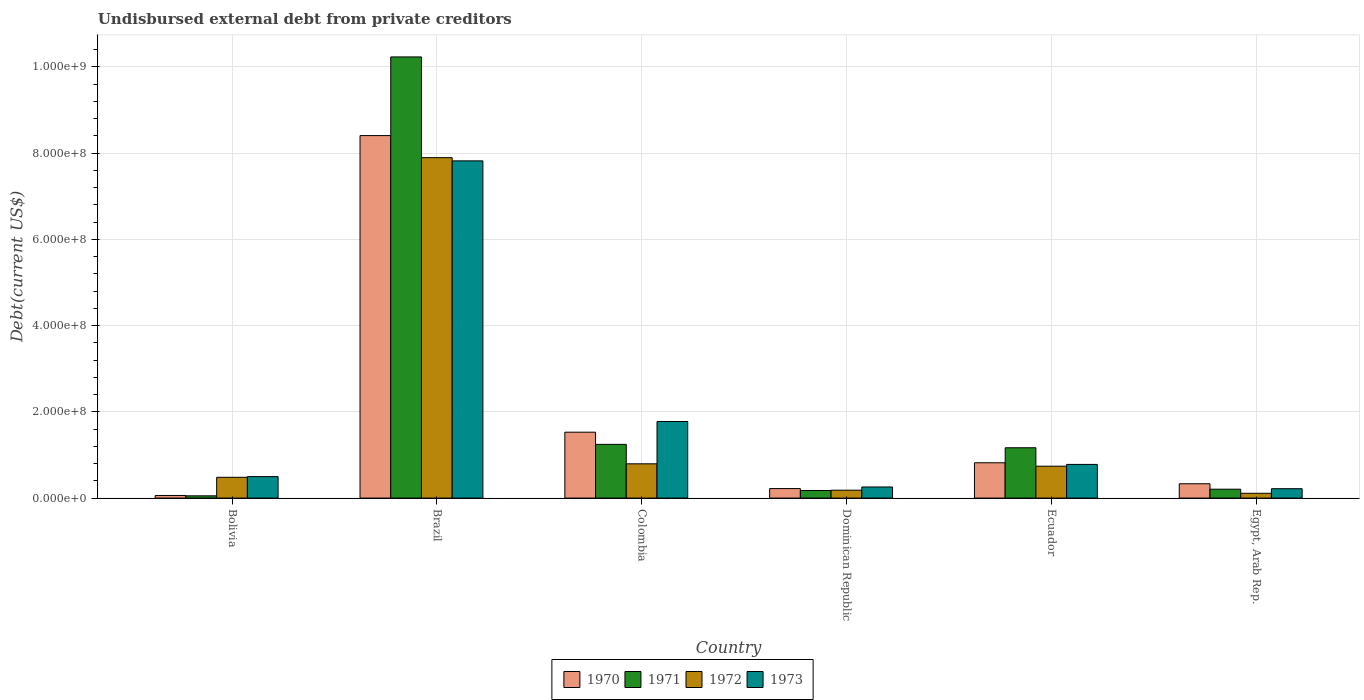Are the number of bars per tick equal to the number of legend labels?
Your answer should be very brief. Yes. How many bars are there on the 4th tick from the right?
Your answer should be very brief. 4. What is the label of the 2nd group of bars from the left?
Ensure brevity in your answer.  Brazil. What is the total debt in 1971 in Bolivia?
Your response must be concise. 5.25e+06. Across all countries, what is the maximum total debt in 1970?
Provide a short and direct response. 8.41e+08. Across all countries, what is the minimum total debt in 1973?
Offer a very short reply. 2.18e+07. In which country was the total debt in 1970 maximum?
Provide a succinct answer. Brazil. In which country was the total debt in 1973 minimum?
Your answer should be very brief. Egypt, Arab Rep. What is the total total debt in 1972 in the graph?
Offer a terse response. 1.02e+09. What is the difference between the total debt in 1971 in Bolivia and that in Brazil?
Ensure brevity in your answer.  -1.02e+09. What is the difference between the total debt in 1970 in Ecuador and the total debt in 1973 in Dominican Republic?
Ensure brevity in your answer.  5.61e+07. What is the average total debt in 1971 per country?
Make the answer very short. 2.18e+08. What is the difference between the total debt of/in 1973 and total debt of/in 1970 in Ecuador?
Your answer should be compact. -3.78e+06. What is the ratio of the total debt in 1972 in Bolivia to that in Ecuador?
Ensure brevity in your answer.  0.65. Is the total debt in 1971 in Bolivia less than that in Dominican Republic?
Give a very brief answer. Yes. Is the difference between the total debt in 1973 in Brazil and Egypt, Arab Rep. greater than the difference between the total debt in 1970 in Brazil and Egypt, Arab Rep.?
Offer a very short reply. No. What is the difference between the highest and the second highest total debt in 1970?
Provide a succinct answer. 7.59e+08. What is the difference between the highest and the lowest total debt in 1972?
Offer a terse response. 7.78e+08. In how many countries, is the total debt in 1971 greater than the average total debt in 1971 taken over all countries?
Offer a very short reply. 1. Is the sum of the total debt in 1972 in Ecuador and Egypt, Arab Rep. greater than the maximum total debt in 1971 across all countries?
Your answer should be compact. No. Is it the case that in every country, the sum of the total debt in 1971 and total debt in 1970 is greater than the sum of total debt in 1973 and total debt in 1972?
Provide a succinct answer. No. Is it the case that in every country, the sum of the total debt in 1973 and total debt in 1972 is greater than the total debt in 1970?
Your answer should be very brief. No. Are all the bars in the graph horizontal?
Offer a terse response. No. How many countries are there in the graph?
Your response must be concise. 6. What is the difference between two consecutive major ticks on the Y-axis?
Give a very brief answer. 2.00e+08. Are the values on the major ticks of Y-axis written in scientific E-notation?
Offer a terse response. Yes. Does the graph contain grids?
Ensure brevity in your answer.  Yes. What is the title of the graph?
Your answer should be very brief. Undisbursed external debt from private creditors. What is the label or title of the X-axis?
Give a very brief answer. Country. What is the label or title of the Y-axis?
Offer a very short reply. Debt(current US$). What is the Debt(current US$) in 1970 in Bolivia?
Your answer should be compact. 6.05e+06. What is the Debt(current US$) in 1971 in Bolivia?
Keep it short and to the point. 5.25e+06. What is the Debt(current US$) in 1972 in Bolivia?
Give a very brief answer. 4.82e+07. What is the Debt(current US$) of 1973 in Bolivia?
Your answer should be compact. 4.98e+07. What is the Debt(current US$) in 1970 in Brazil?
Provide a short and direct response. 8.41e+08. What is the Debt(current US$) in 1971 in Brazil?
Offer a terse response. 1.02e+09. What is the Debt(current US$) in 1972 in Brazil?
Your response must be concise. 7.89e+08. What is the Debt(current US$) of 1973 in Brazil?
Offer a very short reply. 7.82e+08. What is the Debt(current US$) of 1970 in Colombia?
Make the answer very short. 1.53e+08. What is the Debt(current US$) of 1971 in Colombia?
Make the answer very short. 1.25e+08. What is the Debt(current US$) of 1972 in Colombia?
Your answer should be very brief. 7.95e+07. What is the Debt(current US$) in 1973 in Colombia?
Keep it short and to the point. 1.78e+08. What is the Debt(current US$) in 1970 in Dominican Republic?
Provide a succinct answer. 2.21e+07. What is the Debt(current US$) in 1971 in Dominican Republic?
Make the answer very short. 1.76e+07. What is the Debt(current US$) of 1972 in Dominican Republic?
Your answer should be very brief. 1.83e+07. What is the Debt(current US$) in 1973 in Dominican Republic?
Provide a short and direct response. 2.58e+07. What is the Debt(current US$) in 1970 in Ecuador?
Provide a succinct answer. 8.19e+07. What is the Debt(current US$) in 1971 in Ecuador?
Give a very brief answer. 1.17e+08. What is the Debt(current US$) in 1972 in Ecuador?
Your answer should be compact. 7.40e+07. What is the Debt(current US$) of 1973 in Ecuador?
Provide a succinct answer. 7.81e+07. What is the Debt(current US$) of 1970 in Egypt, Arab Rep.?
Offer a very short reply. 3.32e+07. What is the Debt(current US$) in 1971 in Egypt, Arab Rep.?
Ensure brevity in your answer.  2.06e+07. What is the Debt(current US$) in 1972 in Egypt, Arab Rep.?
Provide a succinct answer. 1.11e+07. What is the Debt(current US$) of 1973 in Egypt, Arab Rep.?
Give a very brief answer. 2.18e+07. Across all countries, what is the maximum Debt(current US$) in 1970?
Ensure brevity in your answer.  8.41e+08. Across all countries, what is the maximum Debt(current US$) of 1971?
Your answer should be compact. 1.02e+09. Across all countries, what is the maximum Debt(current US$) of 1972?
Provide a short and direct response. 7.89e+08. Across all countries, what is the maximum Debt(current US$) of 1973?
Offer a very short reply. 7.82e+08. Across all countries, what is the minimum Debt(current US$) of 1970?
Give a very brief answer. 6.05e+06. Across all countries, what is the minimum Debt(current US$) in 1971?
Your answer should be very brief. 5.25e+06. Across all countries, what is the minimum Debt(current US$) of 1972?
Your response must be concise. 1.11e+07. Across all countries, what is the minimum Debt(current US$) in 1973?
Provide a short and direct response. 2.18e+07. What is the total Debt(current US$) in 1970 in the graph?
Keep it short and to the point. 1.14e+09. What is the total Debt(current US$) in 1971 in the graph?
Ensure brevity in your answer.  1.31e+09. What is the total Debt(current US$) in 1972 in the graph?
Keep it short and to the point. 1.02e+09. What is the total Debt(current US$) of 1973 in the graph?
Your answer should be compact. 1.14e+09. What is the difference between the Debt(current US$) of 1970 in Bolivia and that in Brazil?
Your response must be concise. -8.35e+08. What is the difference between the Debt(current US$) in 1971 in Bolivia and that in Brazil?
Provide a short and direct response. -1.02e+09. What is the difference between the Debt(current US$) of 1972 in Bolivia and that in Brazil?
Your response must be concise. -7.41e+08. What is the difference between the Debt(current US$) in 1973 in Bolivia and that in Brazil?
Offer a terse response. -7.32e+08. What is the difference between the Debt(current US$) in 1970 in Bolivia and that in Colombia?
Your answer should be compact. -1.47e+08. What is the difference between the Debt(current US$) of 1971 in Bolivia and that in Colombia?
Keep it short and to the point. -1.19e+08. What is the difference between the Debt(current US$) in 1972 in Bolivia and that in Colombia?
Give a very brief answer. -3.13e+07. What is the difference between the Debt(current US$) in 1973 in Bolivia and that in Colombia?
Offer a terse response. -1.28e+08. What is the difference between the Debt(current US$) of 1970 in Bolivia and that in Dominican Republic?
Ensure brevity in your answer.  -1.60e+07. What is the difference between the Debt(current US$) of 1971 in Bolivia and that in Dominican Republic?
Offer a terse response. -1.24e+07. What is the difference between the Debt(current US$) of 1972 in Bolivia and that in Dominican Republic?
Your answer should be very brief. 2.99e+07. What is the difference between the Debt(current US$) of 1973 in Bolivia and that in Dominican Republic?
Offer a terse response. 2.40e+07. What is the difference between the Debt(current US$) in 1970 in Bolivia and that in Ecuador?
Provide a succinct answer. -7.58e+07. What is the difference between the Debt(current US$) of 1971 in Bolivia and that in Ecuador?
Offer a terse response. -1.11e+08. What is the difference between the Debt(current US$) of 1972 in Bolivia and that in Ecuador?
Your response must be concise. -2.58e+07. What is the difference between the Debt(current US$) of 1973 in Bolivia and that in Ecuador?
Give a very brief answer. -2.83e+07. What is the difference between the Debt(current US$) of 1970 in Bolivia and that in Egypt, Arab Rep.?
Make the answer very short. -2.72e+07. What is the difference between the Debt(current US$) of 1971 in Bolivia and that in Egypt, Arab Rep.?
Your response must be concise. -1.54e+07. What is the difference between the Debt(current US$) of 1972 in Bolivia and that in Egypt, Arab Rep.?
Make the answer very short. 3.71e+07. What is the difference between the Debt(current US$) of 1973 in Bolivia and that in Egypt, Arab Rep.?
Ensure brevity in your answer.  2.80e+07. What is the difference between the Debt(current US$) of 1970 in Brazil and that in Colombia?
Ensure brevity in your answer.  6.88e+08. What is the difference between the Debt(current US$) in 1971 in Brazil and that in Colombia?
Your response must be concise. 8.98e+08. What is the difference between the Debt(current US$) of 1972 in Brazil and that in Colombia?
Provide a short and direct response. 7.10e+08. What is the difference between the Debt(current US$) in 1973 in Brazil and that in Colombia?
Your answer should be compact. 6.04e+08. What is the difference between the Debt(current US$) of 1970 in Brazil and that in Dominican Republic?
Offer a terse response. 8.19e+08. What is the difference between the Debt(current US$) of 1971 in Brazil and that in Dominican Republic?
Offer a very short reply. 1.01e+09. What is the difference between the Debt(current US$) of 1972 in Brazil and that in Dominican Republic?
Give a very brief answer. 7.71e+08. What is the difference between the Debt(current US$) in 1973 in Brazil and that in Dominican Republic?
Provide a short and direct response. 7.56e+08. What is the difference between the Debt(current US$) in 1970 in Brazil and that in Ecuador?
Give a very brief answer. 7.59e+08. What is the difference between the Debt(current US$) of 1971 in Brazil and that in Ecuador?
Ensure brevity in your answer.  9.06e+08. What is the difference between the Debt(current US$) in 1972 in Brazil and that in Ecuador?
Your response must be concise. 7.15e+08. What is the difference between the Debt(current US$) of 1973 in Brazil and that in Ecuador?
Provide a short and direct response. 7.04e+08. What is the difference between the Debt(current US$) of 1970 in Brazil and that in Egypt, Arab Rep.?
Your answer should be compact. 8.07e+08. What is the difference between the Debt(current US$) of 1971 in Brazil and that in Egypt, Arab Rep.?
Provide a succinct answer. 1.00e+09. What is the difference between the Debt(current US$) in 1972 in Brazil and that in Egypt, Arab Rep.?
Your answer should be compact. 7.78e+08. What is the difference between the Debt(current US$) in 1973 in Brazil and that in Egypt, Arab Rep.?
Offer a very short reply. 7.60e+08. What is the difference between the Debt(current US$) in 1970 in Colombia and that in Dominican Republic?
Your answer should be very brief. 1.31e+08. What is the difference between the Debt(current US$) of 1971 in Colombia and that in Dominican Republic?
Your answer should be compact. 1.07e+08. What is the difference between the Debt(current US$) of 1972 in Colombia and that in Dominican Republic?
Your answer should be very brief. 6.12e+07. What is the difference between the Debt(current US$) of 1973 in Colombia and that in Dominican Republic?
Keep it short and to the point. 1.52e+08. What is the difference between the Debt(current US$) of 1970 in Colombia and that in Ecuador?
Offer a terse response. 7.09e+07. What is the difference between the Debt(current US$) in 1971 in Colombia and that in Ecuador?
Offer a terse response. 7.88e+06. What is the difference between the Debt(current US$) in 1972 in Colombia and that in Ecuador?
Make the answer very short. 5.49e+06. What is the difference between the Debt(current US$) of 1973 in Colombia and that in Ecuador?
Ensure brevity in your answer.  9.95e+07. What is the difference between the Debt(current US$) in 1970 in Colombia and that in Egypt, Arab Rep.?
Ensure brevity in your answer.  1.20e+08. What is the difference between the Debt(current US$) of 1971 in Colombia and that in Egypt, Arab Rep.?
Offer a terse response. 1.04e+08. What is the difference between the Debt(current US$) in 1972 in Colombia and that in Egypt, Arab Rep.?
Your answer should be very brief. 6.83e+07. What is the difference between the Debt(current US$) in 1973 in Colombia and that in Egypt, Arab Rep.?
Offer a terse response. 1.56e+08. What is the difference between the Debt(current US$) in 1970 in Dominican Republic and that in Ecuador?
Your answer should be compact. -5.98e+07. What is the difference between the Debt(current US$) in 1971 in Dominican Republic and that in Ecuador?
Make the answer very short. -9.91e+07. What is the difference between the Debt(current US$) in 1972 in Dominican Republic and that in Ecuador?
Your response must be concise. -5.57e+07. What is the difference between the Debt(current US$) in 1973 in Dominican Republic and that in Ecuador?
Give a very brief answer. -5.23e+07. What is the difference between the Debt(current US$) of 1970 in Dominican Republic and that in Egypt, Arab Rep.?
Give a very brief answer. -1.11e+07. What is the difference between the Debt(current US$) in 1971 in Dominican Republic and that in Egypt, Arab Rep.?
Your answer should be compact. -3.00e+06. What is the difference between the Debt(current US$) of 1972 in Dominican Republic and that in Egypt, Arab Rep.?
Your response must be concise. 7.19e+06. What is the difference between the Debt(current US$) of 1973 in Dominican Republic and that in Egypt, Arab Rep.?
Give a very brief answer. 3.97e+06. What is the difference between the Debt(current US$) in 1970 in Ecuador and that in Egypt, Arab Rep.?
Ensure brevity in your answer.  4.87e+07. What is the difference between the Debt(current US$) in 1971 in Ecuador and that in Egypt, Arab Rep.?
Ensure brevity in your answer.  9.61e+07. What is the difference between the Debt(current US$) of 1972 in Ecuador and that in Egypt, Arab Rep.?
Provide a short and direct response. 6.28e+07. What is the difference between the Debt(current US$) of 1973 in Ecuador and that in Egypt, Arab Rep.?
Your answer should be compact. 5.63e+07. What is the difference between the Debt(current US$) of 1970 in Bolivia and the Debt(current US$) of 1971 in Brazil?
Keep it short and to the point. -1.02e+09. What is the difference between the Debt(current US$) of 1970 in Bolivia and the Debt(current US$) of 1972 in Brazil?
Ensure brevity in your answer.  -7.83e+08. What is the difference between the Debt(current US$) of 1970 in Bolivia and the Debt(current US$) of 1973 in Brazil?
Your answer should be compact. -7.76e+08. What is the difference between the Debt(current US$) of 1971 in Bolivia and the Debt(current US$) of 1972 in Brazil?
Provide a short and direct response. -7.84e+08. What is the difference between the Debt(current US$) of 1971 in Bolivia and the Debt(current US$) of 1973 in Brazil?
Your answer should be very brief. -7.77e+08. What is the difference between the Debt(current US$) of 1972 in Bolivia and the Debt(current US$) of 1973 in Brazil?
Your answer should be very brief. -7.34e+08. What is the difference between the Debt(current US$) in 1970 in Bolivia and the Debt(current US$) in 1971 in Colombia?
Offer a terse response. -1.19e+08. What is the difference between the Debt(current US$) in 1970 in Bolivia and the Debt(current US$) in 1972 in Colombia?
Provide a succinct answer. -7.34e+07. What is the difference between the Debt(current US$) in 1970 in Bolivia and the Debt(current US$) in 1973 in Colombia?
Offer a very short reply. -1.72e+08. What is the difference between the Debt(current US$) of 1971 in Bolivia and the Debt(current US$) of 1972 in Colombia?
Provide a succinct answer. -7.42e+07. What is the difference between the Debt(current US$) in 1971 in Bolivia and the Debt(current US$) in 1973 in Colombia?
Provide a short and direct response. -1.72e+08. What is the difference between the Debt(current US$) of 1972 in Bolivia and the Debt(current US$) of 1973 in Colombia?
Give a very brief answer. -1.29e+08. What is the difference between the Debt(current US$) in 1970 in Bolivia and the Debt(current US$) in 1971 in Dominican Republic?
Make the answer very short. -1.16e+07. What is the difference between the Debt(current US$) in 1970 in Bolivia and the Debt(current US$) in 1972 in Dominican Republic?
Offer a very short reply. -1.23e+07. What is the difference between the Debt(current US$) in 1970 in Bolivia and the Debt(current US$) in 1973 in Dominican Republic?
Ensure brevity in your answer.  -1.97e+07. What is the difference between the Debt(current US$) of 1971 in Bolivia and the Debt(current US$) of 1972 in Dominican Republic?
Make the answer very short. -1.31e+07. What is the difference between the Debt(current US$) in 1971 in Bolivia and the Debt(current US$) in 1973 in Dominican Republic?
Your answer should be compact. -2.05e+07. What is the difference between the Debt(current US$) of 1972 in Bolivia and the Debt(current US$) of 1973 in Dominican Republic?
Offer a very short reply. 2.24e+07. What is the difference between the Debt(current US$) of 1970 in Bolivia and the Debt(current US$) of 1971 in Ecuador?
Give a very brief answer. -1.11e+08. What is the difference between the Debt(current US$) of 1970 in Bolivia and the Debt(current US$) of 1972 in Ecuador?
Provide a succinct answer. -6.79e+07. What is the difference between the Debt(current US$) in 1970 in Bolivia and the Debt(current US$) in 1973 in Ecuador?
Provide a short and direct response. -7.21e+07. What is the difference between the Debt(current US$) in 1971 in Bolivia and the Debt(current US$) in 1972 in Ecuador?
Provide a short and direct response. -6.87e+07. What is the difference between the Debt(current US$) in 1971 in Bolivia and the Debt(current US$) in 1973 in Ecuador?
Offer a very short reply. -7.29e+07. What is the difference between the Debt(current US$) of 1972 in Bolivia and the Debt(current US$) of 1973 in Ecuador?
Give a very brief answer. -2.99e+07. What is the difference between the Debt(current US$) in 1970 in Bolivia and the Debt(current US$) in 1971 in Egypt, Arab Rep.?
Your answer should be compact. -1.46e+07. What is the difference between the Debt(current US$) of 1970 in Bolivia and the Debt(current US$) of 1972 in Egypt, Arab Rep.?
Offer a very short reply. -5.08e+06. What is the difference between the Debt(current US$) of 1970 in Bolivia and the Debt(current US$) of 1973 in Egypt, Arab Rep.?
Ensure brevity in your answer.  -1.58e+07. What is the difference between the Debt(current US$) of 1971 in Bolivia and the Debt(current US$) of 1972 in Egypt, Arab Rep.?
Provide a succinct answer. -5.88e+06. What is the difference between the Debt(current US$) in 1971 in Bolivia and the Debt(current US$) in 1973 in Egypt, Arab Rep.?
Make the answer very short. -1.66e+07. What is the difference between the Debt(current US$) in 1972 in Bolivia and the Debt(current US$) in 1973 in Egypt, Arab Rep.?
Make the answer very short. 2.64e+07. What is the difference between the Debt(current US$) of 1970 in Brazil and the Debt(current US$) of 1971 in Colombia?
Make the answer very short. 7.16e+08. What is the difference between the Debt(current US$) in 1970 in Brazil and the Debt(current US$) in 1972 in Colombia?
Make the answer very short. 7.61e+08. What is the difference between the Debt(current US$) of 1970 in Brazil and the Debt(current US$) of 1973 in Colombia?
Provide a succinct answer. 6.63e+08. What is the difference between the Debt(current US$) of 1971 in Brazil and the Debt(current US$) of 1972 in Colombia?
Your answer should be compact. 9.44e+08. What is the difference between the Debt(current US$) in 1971 in Brazil and the Debt(current US$) in 1973 in Colombia?
Offer a terse response. 8.45e+08. What is the difference between the Debt(current US$) of 1972 in Brazil and the Debt(current US$) of 1973 in Colombia?
Provide a succinct answer. 6.12e+08. What is the difference between the Debt(current US$) in 1970 in Brazil and the Debt(current US$) in 1971 in Dominican Republic?
Provide a short and direct response. 8.23e+08. What is the difference between the Debt(current US$) of 1970 in Brazil and the Debt(current US$) of 1972 in Dominican Republic?
Offer a very short reply. 8.22e+08. What is the difference between the Debt(current US$) of 1970 in Brazil and the Debt(current US$) of 1973 in Dominican Republic?
Ensure brevity in your answer.  8.15e+08. What is the difference between the Debt(current US$) of 1971 in Brazil and the Debt(current US$) of 1972 in Dominican Republic?
Your answer should be very brief. 1.00e+09. What is the difference between the Debt(current US$) of 1971 in Brazil and the Debt(current US$) of 1973 in Dominican Republic?
Provide a short and direct response. 9.97e+08. What is the difference between the Debt(current US$) of 1972 in Brazil and the Debt(current US$) of 1973 in Dominican Republic?
Offer a very short reply. 7.64e+08. What is the difference between the Debt(current US$) of 1970 in Brazil and the Debt(current US$) of 1971 in Ecuador?
Provide a short and direct response. 7.24e+08. What is the difference between the Debt(current US$) of 1970 in Brazil and the Debt(current US$) of 1972 in Ecuador?
Offer a terse response. 7.67e+08. What is the difference between the Debt(current US$) in 1970 in Brazil and the Debt(current US$) in 1973 in Ecuador?
Provide a short and direct response. 7.63e+08. What is the difference between the Debt(current US$) in 1971 in Brazil and the Debt(current US$) in 1972 in Ecuador?
Give a very brief answer. 9.49e+08. What is the difference between the Debt(current US$) in 1971 in Brazil and the Debt(current US$) in 1973 in Ecuador?
Offer a terse response. 9.45e+08. What is the difference between the Debt(current US$) in 1972 in Brazil and the Debt(current US$) in 1973 in Ecuador?
Offer a terse response. 7.11e+08. What is the difference between the Debt(current US$) in 1970 in Brazil and the Debt(current US$) in 1971 in Egypt, Arab Rep.?
Offer a terse response. 8.20e+08. What is the difference between the Debt(current US$) of 1970 in Brazil and the Debt(current US$) of 1972 in Egypt, Arab Rep.?
Offer a very short reply. 8.29e+08. What is the difference between the Debt(current US$) of 1970 in Brazil and the Debt(current US$) of 1973 in Egypt, Arab Rep.?
Offer a terse response. 8.19e+08. What is the difference between the Debt(current US$) of 1971 in Brazil and the Debt(current US$) of 1972 in Egypt, Arab Rep.?
Your answer should be very brief. 1.01e+09. What is the difference between the Debt(current US$) of 1971 in Brazil and the Debt(current US$) of 1973 in Egypt, Arab Rep.?
Offer a terse response. 1.00e+09. What is the difference between the Debt(current US$) of 1972 in Brazil and the Debt(current US$) of 1973 in Egypt, Arab Rep.?
Provide a short and direct response. 7.68e+08. What is the difference between the Debt(current US$) of 1970 in Colombia and the Debt(current US$) of 1971 in Dominican Republic?
Your response must be concise. 1.35e+08. What is the difference between the Debt(current US$) in 1970 in Colombia and the Debt(current US$) in 1972 in Dominican Republic?
Your answer should be compact. 1.34e+08. What is the difference between the Debt(current US$) of 1970 in Colombia and the Debt(current US$) of 1973 in Dominican Republic?
Your answer should be compact. 1.27e+08. What is the difference between the Debt(current US$) in 1971 in Colombia and the Debt(current US$) in 1972 in Dominican Republic?
Provide a short and direct response. 1.06e+08. What is the difference between the Debt(current US$) of 1971 in Colombia and the Debt(current US$) of 1973 in Dominican Republic?
Keep it short and to the point. 9.88e+07. What is the difference between the Debt(current US$) of 1972 in Colombia and the Debt(current US$) of 1973 in Dominican Republic?
Make the answer very short. 5.37e+07. What is the difference between the Debt(current US$) in 1970 in Colombia and the Debt(current US$) in 1971 in Ecuador?
Your response must be concise. 3.61e+07. What is the difference between the Debt(current US$) in 1970 in Colombia and the Debt(current US$) in 1972 in Ecuador?
Offer a very short reply. 7.88e+07. What is the difference between the Debt(current US$) in 1970 in Colombia and the Debt(current US$) in 1973 in Ecuador?
Provide a succinct answer. 7.47e+07. What is the difference between the Debt(current US$) of 1971 in Colombia and the Debt(current US$) of 1972 in Ecuador?
Your answer should be very brief. 5.06e+07. What is the difference between the Debt(current US$) of 1971 in Colombia and the Debt(current US$) of 1973 in Ecuador?
Ensure brevity in your answer.  4.65e+07. What is the difference between the Debt(current US$) in 1972 in Colombia and the Debt(current US$) in 1973 in Ecuador?
Offer a terse response. 1.36e+06. What is the difference between the Debt(current US$) in 1970 in Colombia and the Debt(current US$) in 1971 in Egypt, Arab Rep.?
Offer a very short reply. 1.32e+08. What is the difference between the Debt(current US$) of 1970 in Colombia and the Debt(current US$) of 1972 in Egypt, Arab Rep.?
Provide a short and direct response. 1.42e+08. What is the difference between the Debt(current US$) of 1970 in Colombia and the Debt(current US$) of 1973 in Egypt, Arab Rep.?
Provide a succinct answer. 1.31e+08. What is the difference between the Debt(current US$) of 1971 in Colombia and the Debt(current US$) of 1972 in Egypt, Arab Rep.?
Provide a short and direct response. 1.13e+08. What is the difference between the Debt(current US$) in 1971 in Colombia and the Debt(current US$) in 1973 in Egypt, Arab Rep.?
Offer a very short reply. 1.03e+08. What is the difference between the Debt(current US$) of 1972 in Colombia and the Debt(current US$) of 1973 in Egypt, Arab Rep.?
Your answer should be compact. 5.77e+07. What is the difference between the Debt(current US$) of 1970 in Dominican Republic and the Debt(current US$) of 1971 in Ecuador?
Your response must be concise. -9.46e+07. What is the difference between the Debt(current US$) in 1970 in Dominican Republic and the Debt(current US$) in 1972 in Ecuador?
Your answer should be compact. -5.19e+07. What is the difference between the Debt(current US$) in 1970 in Dominican Republic and the Debt(current US$) in 1973 in Ecuador?
Make the answer very short. -5.60e+07. What is the difference between the Debt(current US$) of 1971 in Dominican Republic and the Debt(current US$) of 1972 in Ecuador?
Make the answer very short. -5.63e+07. What is the difference between the Debt(current US$) of 1971 in Dominican Republic and the Debt(current US$) of 1973 in Ecuador?
Make the answer very short. -6.05e+07. What is the difference between the Debt(current US$) of 1972 in Dominican Republic and the Debt(current US$) of 1973 in Ecuador?
Provide a succinct answer. -5.98e+07. What is the difference between the Debt(current US$) of 1970 in Dominican Republic and the Debt(current US$) of 1971 in Egypt, Arab Rep.?
Offer a terse response. 1.46e+06. What is the difference between the Debt(current US$) of 1970 in Dominican Republic and the Debt(current US$) of 1972 in Egypt, Arab Rep.?
Offer a very short reply. 1.10e+07. What is the difference between the Debt(current US$) in 1970 in Dominican Republic and the Debt(current US$) in 1973 in Egypt, Arab Rep.?
Offer a terse response. 2.96e+05. What is the difference between the Debt(current US$) in 1971 in Dominican Republic and the Debt(current US$) in 1972 in Egypt, Arab Rep.?
Give a very brief answer. 6.50e+06. What is the difference between the Debt(current US$) of 1971 in Dominican Republic and the Debt(current US$) of 1973 in Egypt, Arab Rep.?
Ensure brevity in your answer.  -4.17e+06. What is the difference between the Debt(current US$) in 1972 in Dominican Republic and the Debt(current US$) in 1973 in Egypt, Arab Rep.?
Your answer should be compact. -3.48e+06. What is the difference between the Debt(current US$) of 1970 in Ecuador and the Debt(current US$) of 1971 in Egypt, Arab Rep.?
Provide a short and direct response. 6.13e+07. What is the difference between the Debt(current US$) in 1970 in Ecuador and the Debt(current US$) in 1972 in Egypt, Arab Rep.?
Offer a very short reply. 7.08e+07. What is the difference between the Debt(current US$) in 1970 in Ecuador and the Debt(current US$) in 1973 in Egypt, Arab Rep.?
Offer a terse response. 6.01e+07. What is the difference between the Debt(current US$) in 1971 in Ecuador and the Debt(current US$) in 1972 in Egypt, Arab Rep.?
Offer a terse response. 1.06e+08. What is the difference between the Debt(current US$) of 1971 in Ecuador and the Debt(current US$) of 1973 in Egypt, Arab Rep.?
Your answer should be compact. 9.49e+07. What is the difference between the Debt(current US$) in 1972 in Ecuador and the Debt(current US$) in 1973 in Egypt, Arab Rep.?
Your answer should be compact. 5.22e+07. What is the average Debt(current US$) in 1970 per country?
Your answer should be compact. 1.89e+08. What is the average Debt(current US$) in 1971 per country?
Offer a terse response. 2.18e+08. What is the average Debt(current US$) in 1972 per country?
Your answer should be very brief. 1.70e+08. What is the average Debt(current US$) of 1973 per country?
Provide a succinct answer. 1.89e+08. What is the difference between the Debt(current US$) of 1970 and Debt(current US$) of 1971 in Bolivia?
Make the answer very short. 8.02e+05. What is the difference between the Debt(current US$) in 1970 and Debt(current US$) in 1972 in Bolivia?
Your answer should be compact. -4.22e+07. What is the difference between the Debt(current US$) in 1970 and Debt(current US$) in 1973 in Bolivia?
Your answer should be compact. -4.37e+07. What is the difference between the Debt(current US$) of 1971 and Debt(current US$) of 1972 in Bolivia?
Your answer should be very brief. -4.30e+07. What is the difference between the Debt(current US$) of 1971 and Debt(current US$) of 1973 in Bolivia?
Your answer should be compact. -4.45e+07. What is the difference between the Debt(current US$) in 1972 and Debt(current US$) in 1973 in Bolivia?
Make the answer very short. -1.58e+06. What is the difference between the Debt(current US$) in 1970 and Debt(current US$) in 1971 in Brazil?
Keep it short and to the point. -1.82e+08. What is the difference between the Debt(current US$) in 1970 and Debt(current US$) in 1972 in Brazil?
Give a very brief answer. 5.12e+07. What is the difference between the Debt(current US$) of 1970 and Debt(current US$) of 1973 in Brazil?
Ensure brevity in your answer.  5.86e+07. What is the difference between the Debt(current US$) in 1971 and Debt(current US$) in 1972 in Brazil?
Offer a very short reply. 2.34e+08. What is the difference between the Debt(current US$) in 1971 and Debt(current US$) in 1973 in Brazil?
Keep it short and to the point. 2.41e+08. What is the difference between the Debt(current US$) of 1972 and Debt(current US$) of 1973 in Brazil?
Provide a short and direct response. 7.41e+06. What is the difference between the Debt(current US$) in 1970 and Debt(current US$) in 1971 in Colombia?
Give a very brief answer. 2.82e+07. What is the difference between the Debt(current US$) in 1970 and Debt(current US$) in 1972 in Colombia?
Provide a succinct answer. 7.33e+07. What is the difference between the Debt(current US$) in 1970 and Debt(current US$) in 1973 in Colombia?
Provide a succinct answer. -2.48e+07. What is the difference between the Debt(current US$) in 1971 and Debt(current US$) in 1972 in Colombia?
Ensure brevity in your answer.  4.51e+07. What is the difference between the Debt(current US$) of 1971 and Debt(current US$) of 1973 in Colombia?
Give a very brief answer. -5.30e+07. What is the difference between the Debt(current US$) of 1972 and Debt(current US$) of 1973 in Colombia?
Give a very brief answer. -9.81e+07. What is the difference between the Debt(current US$) in 1970 and Debt(current US$) in 1971 in Dominican Republic?
Offer a terse response. 4.46e+06. What is the difference between the Debt(current US$) of 1970 and Debt(current US$) of 1972 in Dominican Republic?
Your answer should be very brief. 3.78e+06. What is the difference between the Debt(current US$) in 1970 and Debt(current US$) in 1973 in Dominican Republic?
Offer a terse response. -3.68e+06. What is the difference between the Debt(current US$) of 1971 and Debt(current US$) of 1972 in Dominican Republic?
Your answer should be very brief. -6.84e+05. What is the difference between the Debt(current US$) of 1971 and Debt(current US$) of 1973 in Dominican Republic?
Your answer should be very brief. -8.14e+06. What is the difference between the Debt(current US$) in 1972 and Debt(current US$) in 1973 in Dominican Republic?
Provide a succinct answer. -7.46e+06. What is the difference between the Debt(current US$) in 1970 and Debt(current US$) in 1971 in Ecuador?
Your answer should be very brief. -3.48e+07. What is the difference between the Debt(current US$) in 1970 and Debt(current US$) in 1972 in Ecuador?
Offer a terse response. 7.92e+06. What is the difference between the Debt(current US$) in 1970 and Debt(current US$) in 1973 in Ecuador?
Your answer should be compact. 3.78e+06. What is the difference between the Debt(current US$) in 1971 and Debt(current US$) in 1972 in Ecuador?
Give a very brief answer. 4.27e+07. What is the difference between the Debt(current US$) in 1971 and Debt(current US$) in 1973 in Ecuador?
Your answer should be compact. 3.86e+07. What is the difference between the Debt(current US$) in 1972 and Debt(current US$) in 1973 in Ecuador?
Your answer should be compact. -4.14e+06. What is the difference between the Debt(current US$) of 1970 and Debt(current US$) of 1971 in Egypt, Arab Rep.?
Provide a succinct answer. 1.26e+07. What is the difference between the Debt(current US$) of 1970 and Debt(current US$) of 1972 in Egypt, Arab Rep.?
Your response must be concise. 2.21e+07. What is the difference between the Debt(current US$) of 1970 and Debt(current US$) of 1973 in Egypt, Arab Rep.?
Provide a short and direct response. 1.14e+07. What is the difference between the Debt(current US$) of 1971 and Debt(current US$) of 1972 in Egypt, Arab Rep.?
Your response must be concise. 9.50e+06. What is the difference between the Debt(current US$) of 1971 and Debt(current US$) of 1973 in Egypt, Arab Rep.?
Make the answer very short. -1.17e+06. What is the difference between the Debt(current US$) of 1972 and Debt(current US$) of 1973 in Egypt, Arab Rep.?
Give a very brief answer. -1.07e+07. What is the ratio of the Debt(current US$) of 1970 in Bolivia to that in Brazil?
Provide a short and direct response. 0.01. What is the ratio of the Debt(current US$) in 1971 in Bolivia to that in Brazil?
Provide a short and direct response. 0.01. What is the ratio of the Debt(current US$) of 1972 in Bolivia to that in Brazil?
Offer a terse response. 0.06. What is the ratio of the Debt(current US$) in 1973 in Bolivia to that in Brazil?
Your response must be concise. 0.06. What is the ratio of the Debt(current US$) in 1970 in Bolivia to that in Colombia?
Ensure brevity in your answer.  0.04. What is the ratio of the Debt(current US$) of 1971 in Bolivia to that in Colombia?
Keep it short and to the point. 0.04. What is the ratio of the Debt(current US$) of 1972 in Bolivia to that in Colombia?
Your response must be concise. 0.61. What is the ratio of the Debt(current US$) of 1973 in Bolivia to that in Colombia?
Offer a very short reply. 0.28. What is the ratio of the Debt(current US$) in 1970 in Bolivia to that in Dominican Republic?
Ensure brevity in your answer.  0.27. What is the ratio of the Debt(current US$) of 1971 in Bolivia to that in Dominican Republic?
Provide a short and direct response. 0.3. What is the ratio of the Debt(current US$) in 1972 in Bolivia to that in Dominican Republic?
Provide a short and direct response. 2.63. What is the ratio of the Debt(current US$) in 1973 in Bolivia to that in Dominican Republic?
Your answer should be very brief. 1.93. What is the ratio of the Debt(current US$) of 1970 in Bolivia to that in Ecuador?
Ensure brevity in your answer.  0.07. What is the ratio of the Debt(current US$) in 1971 in Bolivia to that in Ecuador?
Offer a very short reply. 0.04. What is the ratio of the Debt(current US$) in 1972 in Bolivia to that in Ecuador?
Provide a succinct answer. 0.65. What is the ratio of the Debt(current US$) in 1973 in Bolivia to that in Ecuador?
Provide a short and direct response. 0.64. What is the ratio of the Debt(current US$) of 1970 in Bolivia to that in Egypt, Arab Rep.?
Your answer should be compact. 0.18. What is the ratio of the Debt(current US$) in 1971 in Bolivia to that in Egypt, Arab Rep.?
Offer a very short reply. 0.25. What is the ratio of the Debt(current US$) in 1972 in Bolivia to that in Egypt, Arab Rep.?
Offer a terse response. 4.33. What is the ratio of the Debt(current US$) in 1973 in Bolivia to that in Egypt, Arab Rep.?
Offer a very short reply. 2.28. What is the ratio of the Debt(current US$) of 1970 in Brazil to that in Colombia?
Offer a terse response. 5.5. What is the ratio of the Debt(current US$) of 1971 in Brazil to that in Colombia?
Make the answer very short. 8.21. What is the ratio of the Debt(current US$) of 1972 in Brazil to that in Colombia?
Make the answer very short. 9.93. What is the ratio of the Debt(current US$) in 1973 in Brazil to that in Colombia?
Provide a succinct answer. 4.4. What is the ratio of the Debt(current US$) in 1970 in Brazil to that in Dominican Republic?
Your answer should be very brief. 38.04. What is the ratio of the Debt(current US$) of 1971 in Brazil to that in Dominican Republic?
Offer a very short reply. 58.02. What is the ratio of the Debt(current US$) in 1972 in Brazil to that in Dominican Republic?
Offer a very short reply. 43.1. What is the ratio of the Debt(current US$) in 1973 in Brazil to that in Dominican Republic?
Provide a short and direct response. 30.34. What is the ratio of the Debt(current US$) in 1970 in Brazil to that in Ecuador?
Provide a short and direct response. 10.26. What is the ratio of the Debt(current US$) of 1971 in Brazil to that in Ecuador?
Give a very brief answer. 8.76. What is the ratio of the Debt(current US$) in 1972 in Brazil to that in Ecuador?
Provide a short and direct response. 10.67. What is the ratio of the Debt(current US$) of 1973 in Brazil to that in Ecuador?
Your answer should be compact. 10.01. What is the ratio of the Debt(current US$) of 1970 in Brazil to that in Egypt, Arab Rep.?
Provide a short and direct response. 25.3. What is the ratio of the Debt(current US$) in 1971 in Brazil to that in Egypt, Arab Rep.?
Your answer should be very brief. 49.58. What is the ratio of the Debt(current US$) of 1972 in Brazil to that in Egypt, Arab Rep.?
Offer a very short reply. 70.94. What is the ratio of the Debt(current US$) of 1973 in Brazil to that in Egypt, Arab Rep.?
Keep it short and to the point. 35.87. What is the ratio of the Debt(current US$) of 1970 in Colombia to that in Dominican Republic?
Your response must be concise. 6.92. What is the ratio of the Debt(current US$) in 1971 in Colombia to that in Dominican Republic?
Give a very brief answer. 7.07. What is the ratio of the Debt(current US$) in 1972 in Colombia to that in Dominican Republic?
Your response must be concise. 4.34. What is the ratio of the Debt(current US$) of 1973 in Colombia to that in Dominican Republic?
Your answer should be very brief. 6.89. What is the ratio of the Debt(current US$) in 1970 in Colombia to that in Ecuador?
Offer a terse response. 1.87. What is the ratio of the Debt(current US$) of 1971 in Colombia to that in Ecuador?
Keep it short and to the point. 1.07. What is the ratio of the Debt(current US$) in 1972 in Colombia to that in Ecuador?
Provide a succinct answer. 1.07. What is the ratio of the Debt(current US$) of 1973 in Colombia to that in Ecuador?
Your response must be concise. 2.27. What is the ratio of the Debt(current US$) of 1970 in Colombia to that in Egypt, Arab Rep.?
Give a very brief answer. 4.6. What is the ratio of the Debt(current US$) in 1971 in Colombia to that in Egypt, Arab Rep.?
Keep it short and to the point. 6.04. What is the ratio of the Debt(current US$) of 1972 in Colombia to that in Egypt, Arab Rep.?
Your response must be concise. 7.14. What is the ratio of the Debt(current US$) in 1973 in Colombia to that in Egypt, Arab Rep.?
Offer a terse response. 8.15. What is the ratio of the Debt(current US$) of 1970 in Dominican Republic to that in Ecuador?
Offer a terse response. 0.27. What is the ratio of the Debt(current US$) in 1971 in Dominican Republic to that in Ecuador?
Your response must be concise. 0.15. What is the ratio of the Debt(current US$) of 1972 in Dominican Republic to that in Ecuador?
Provide a short and direct response. 0.25. What is the ratio of the Debt(current US$) in 1973 in Dominican Republic to that in Ecuador?
Ensure brevity in your answer.  0.33. What is the ratio of the Debt(current US$) in 1970 in Dominican Republic to that in Egypt, Arab Rep.?
Provide a succinct answer. 0.67. What is the ratio of the Debt(current US$) of 1971 in Dominican Republic to that in Egypt, Arab Rep.?
Your answer should be compact. 0.85. What is the ratio of the Debt(current US$) in 1972 in Dominican Republic to that in Egypt, Arab Rep.?
Keep it short and to the point. 1.65. What is the ratio of the Debt(current US$) in 1973 in Dominican Republic to that in Egypt, Arab Rep.?
Make the answer very short. 1.18. What is the ratio of the Debt(current US$) of 1970 in Ecuador to that in Egypt, Arab Rep.?
Offer a very short reply. 2.47. What is the ratio of the Debt(current US$) in 1971 in Ecuador to that in Egypt, Arab Rep.?
Make the answer very short. 5.66. What is the ratio of the Debt(current US$) of 1972 in Ecuador to that in Egypt, Arab Rep.?
Your response must be concise. 6.65. What is the ratio of the Debt(current US$) in 1973 in Ecuador to that in Egypt, Arab Rep.?
Offer a terse response. 3.58. What is the difference between the highest and the second highest Debt(current US$) in 1970?
Provide a succinct answer. 6.88e+08. What is the difference between the highest and the second highest Debt(current US$) of 1971?
Provide a succinct answer. 8.98e+08. What is the difference between the highest and the second highest Debt(current US$) in 1972?
Your answer should be very brief. 7.10e+08. What is the difference between the highest and the second highest Debt(current US$) of 1973?
Keep it short and to the point. 6.04e+08. What is the difference between the highest and the lowest Debt(current US$) of 1970?
Provide a short and direct response. 8.35e+08. What is the difference between the highest and the lowest Debt(current US$) of 1971?
Ensure brevity in your answer.  1.02e+09. What is the difference between the highest and the lowest Debt(current US$) of 1972?
Offer a very short reply. 7.78e+08. What is the difference between the highest and the lowest Debt(current US$) of 1973?
Give a very brief answer. 7.60e+08. 